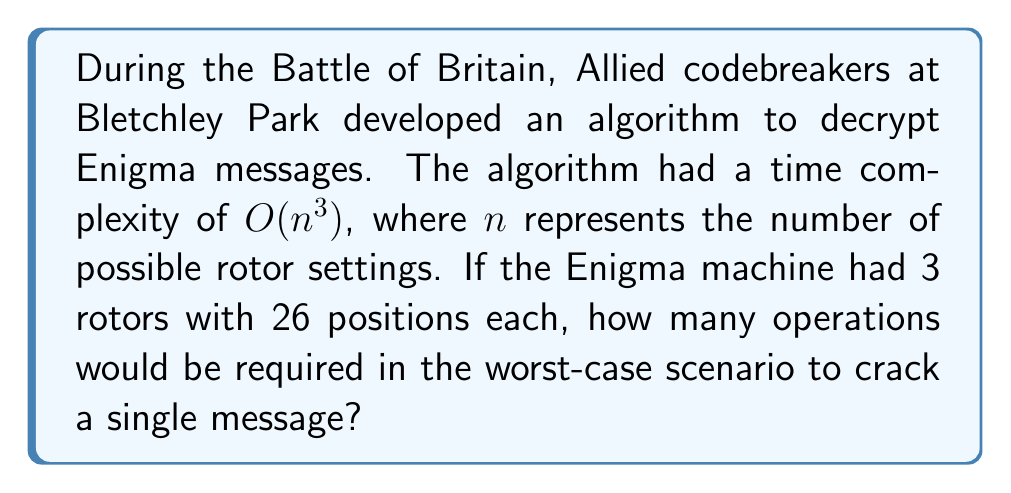Teach me how to tackle this problem. To solve this problem, we need to follow these steps:

1. Determine the total number of possible rotor settings:
   - Each rotor has 26 positions (one for each letter of the alphabet)
   - There are 3 rotors
   - Total combinations = $26^3 = 17,576$

2. Apply the time complexity formula:
   - The algorithm has a time complexity of $O(n^3)$
   - $n$ represents the number of possible rotor settings, which we calculated as 17,576
   - Worst-case number of operations = $n^3 = 17,576^3$

3. Calculate the final result:
   $$(17,576)^3 = 5,429,503,678,976$$

This enormous number illustrates the immense computational challenge faced by the codebreakers at Bletchley Park. It's worth noting that in reality, they developed more sophisticated methods, such as the Bombe machine, to drastically reduce the time needed to decrypt Enigma messages.
Answer: $5,429,503,678,976$ operations 